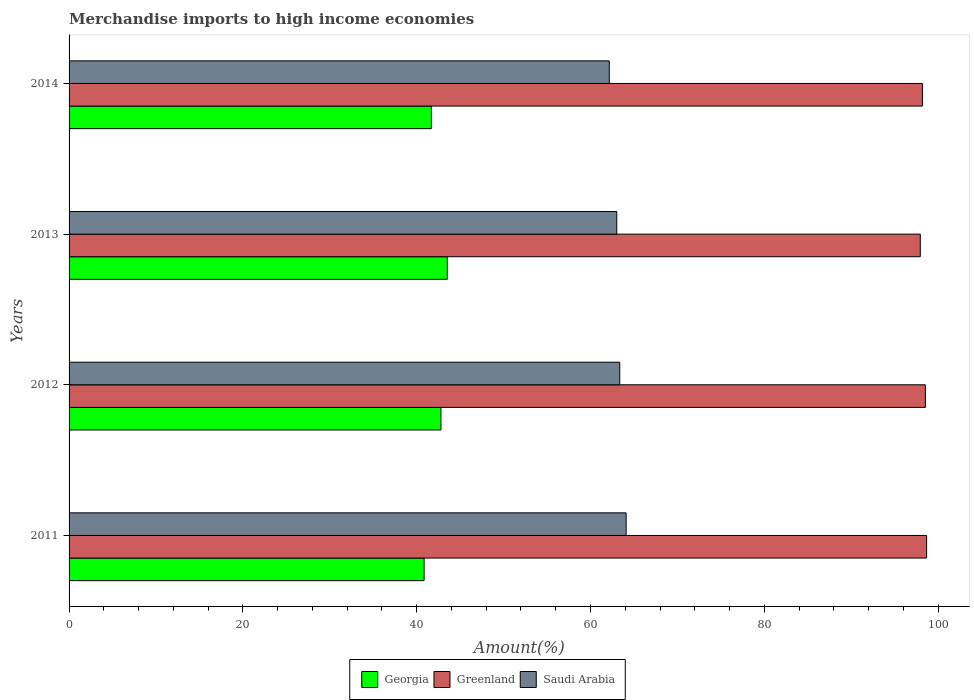How many different coloured bars are there?
Provide a succinct answer. 3. Are the number of bars on each tick of the Y-axis equal?
Offer a very short reply. Yes. How many bars are there on the 1st tick from the top?
Give a very brief answer. 3. What is the label of the 3rd group of bars from the top?
Offer a terse response. 2012. In how many cases, is the number of bars for a given year not equal to the number of legend labels?
Your response must be concise. 0. What is the percentage of amount earned from merchandise imports in Saudi Arabia in 2012?
Your answer should be very brief. 63.37. Across all years, what is the maximum percentage of amount earned from merchandise imports in Greenland?
Ensure brevity in your answer.  98.68. Across all years, what is the minimum percentage of amount earned from merchandise imports in Saudi Arabia?
Offer a very short reply. 62.16. In which year was the percentage of amount earned from merchandise imports in Saudi Arabia maximum?
Ensure brevity in your answer.  2011. What is the total percentage of amount earned from merchandise imports in Saudi Arabia in the graph?
Offer a very short reply. 252.65. What is the difference between the percentage of amount earned from merchandise imports in Georgia in 2012 and that in 2014?
Provide a succinct answer. 1.1. What is the difference between the percentage of amount earned from merchandise imports in Saudi Arabia in 2014 and the percentage of amount earned from merchandise imports in Georgia in 2013?
Offer a terse response. 18.64. What is the average percentage of amount earned from merchandise imports in Greenland per year?
Your response must be concise. 98.34. In the year 2013, what is the difference between the percentage of amount earned from merchandise imports in Saudi Arabia and percentage of amount earned from merchandise imports in Georgia?
Provide a short and direct response. 19.5. What is the ratio of the percentage of amount earned from merchandise imports in Greenland in 2011 to that in 2012?
Your response must be concise. 1. Is the percentage of amount earned from merchandise imports in Saudi Arabia in 2011 less than that in 2012?
Offer a very short reply. No. What is the difference between the highest and the second highest percentage of amount earned from merchandise imports in Georgia?
Your answer should be very brief. 0.73. What is the difference between the highest and the lowest percentage of amount earned from merchandise imports in Georgia?
Offer a terse response. 2.67. Is the sum of the percentage of amount earned from merchandise imports in Greenland in 2011 and 2013 greater than the maximum percentage of amount earned from merchandise imports in Saudi Arabia across all years?
Your response must be concise. Yes. What does the 2nd bar from the top in 2013 represents?
Ensure brevity in your answer.  Greenland. What does the 2nd bar from the bottom in 2014 represents?
Ensure brevity in your answer.  Greenland. How many bars are there?
Offer a very short reply. 12. What is the difference between two consecutive major ticks on the X-axis?
Keep it short and to the point. 20. Does the graph contain any zero values?
Provide a short and direct response. No. Does the graph contain grids?
Offer a very short reply. No. How many legend labels are there?
Provide a short and direct response. 3. How are the legend labels stacked?
Provide a succinct answer. Horizontal. What is the title of the graph?
Keep it short and to the point. Merchandise imports to high income economies. What is the label or title of the X-axis?
Offer a very short reply. Amount(%). What is the Amount(%) of Georgia in 2011?
Offer a very short reply. 40.85. What is the Amount(%) of Greenland in 2011?
Provide a short and direct response. 98.68. What is the Amount(%) in Saudi Arabia in 2011?
Give a very brief answer. 64.1. What is the Amount(%) of Georgia in 2012?
Give a very brief answer. 42.79. What is the Amount(%) of Greenland in 2012?
Provide a short and direct response. 98.54. What is the Amount(%) in Saudi Arabia in 2012?
Offer a terse response. 63.37. What is the Amount(%) of Georgia in 2013?
Provide a short and direct response. 43.52. What is the Amount(%) of Greenland in 2013?
Ensure brevity in your answer.  97.95. What is the Amount(%) in Saudi Arabia in 2013?
Keep it short and to the point. 63.02. What is the Amount(%) of Georgia in 2014?
Offer a very short reply. 41.69. What is the Amount(%) in Greenland in 2014?
Provide a short and direct response. 98.2. What is the Amount(%) in Saudi Arabia in 2014?
Your answer should be compact. 62.16. Across all years, what is the maximum Amount(%) in Georgia?
Give a very brief answer. 43.52. Across all years, what is the maximum Amount(%) of Greenland?
Provide a short and direct response. 98.68. Across all years, what is the maximum Amount(%) of Saudi Arabia?
Give a very brief answer. 64.1. Across all years, what is the minimum Amount(%) of Georgia?
Offer a very short reply. 40.85. Across all years, what is the minimum Amount(%) in Greenland?
Offer a terse response. 97.95. Across all years, what is the minimum Amount(%) in Saudi Arabia?
Offer a terse response. 62.16. What is the total Amount(%) of Georgia in the graph?
Your response must be concise. 168.86. What is the total Amount(%) in Greenland in the graph?
Offer a very short reply. 393.36. What is the total Amount(%) in Saudi Arabia in the graph?
Provide a short and direct response. 252.65. What is the difference between the Amount(%) of Georgia in 2011 and that in 2012?
Make the answer very short. -1.94. What is the difference between the Amount(%) of Greenland in 2011 and that in 2012?
Offer a very short reply. 0.14. What is the difference between the Amount(%) in Saudi Arabia in 2011 and that in 2012?
Offer a terse response. 0.74. What is the difference between the Amount(%) of Georgia in 2011 and that in 2013?
Your answer should be very brief. -2.67. What is the difference between the Amount(%) of Greenland in 2011 and that in 2013?
Provide a short and direct response. 0.73. What is the difference between the Amount(%) in Saudi Arabia in 2011 and that in 2013?
Your response must be concise. 1.08. What is the difference between the Amount(%) in Georgia in 2011 and that in 2014?
Give a very brief answer. -0.84. What is the difference between the Amount(%) in Greenland in 2011 and that in 2014?
Ensure brevity in your answer.  0.48. What is the difference between the Amount(%) of Saudi Arabia in 2011 and that in 2014?
Provide a short and direct response. 1.94. What is the difference between the Amount(%) in Georgia in 2012 and that in 2013?
Offer a terse response. -0.73. What is the difference between the Amount(%) of Greenland in 2012 and that in 2013?
Make the answer very short. 0.59. What is the difference between the Amount(%) of Saudi Arabia in 2012 and that in 2013?
Your response must be concise. 0.34. What is the difference between the Amount(%) of Georgia in 2012 and that in 2014?
Your response must be concise. 1.1. What is the difference between the Amount(%) of Greenland in 2012 and that in 2014?
Make the answer very short. 0.34. What is the difference between the Amount(%) of Saudi Arabia in 2012 and that in 2014?
Your response must be concise. 1.2. What is the difference between the Amount(%) in Georgia in 2013 and that in 2014?
Offer a very short reply. 1.83. What is the difference between the Amount(%) of Greenland in 2013 and that in 2014?
Make the answer very short. -0.25. What is the difference between the Amount(%) in Saudi Arabia in 2013 and that in 2014?
Offer a terse response. 0.86. What is the difference between the Amount(%) in Georgia in 2011 and the Amount(%) in Greenland in 2012?
Provide a succinct answer. -57.68. What is the difference between the Amount(%) in Georgia in 2011 and the Amount(%) in Saudi Arabia in 2012?
Give a very brief answer. -22.51. What is the difference between the Amount(%) of Greenland in 2011 and the Amount(%) of Saudi Arabia in 2012?
Give a very brief answer. 35.31. What is the difference between the Amount(%) of Georgia in 2011 and the Amount(%) of Greenland in 2013?
Keep it short and to the point. -57.1. What is the difference between the Amount(%) of Georgia in 2011 and the Amount(%) of Saudi Arabia in 2013?
Keep it short and to the point. -22.17. What is the difference between the Amount(%) in Greenland in 2011 and the Amount(%) in Saudi Arabia in 2013?
Offer a terse response. 35.65. What is the difference between the Amount(%) of Georgia in 2011 and the Amount(%) of Greenland in 2014?
Keep it short and to the point. -57.34. What is the difference between the Amount(%) in Georgia in 2011 and the Amount(%) in Saudi Arabia in 2014?
Your answer should be very brief. -21.31. What is the difference between the Amount(%) of Greenland in 2011 and the Amount(%) of Saudi Arabia in 2014?
Ensure brevity in your answer.  36.52. What is the difference between the Amount(%) of Georgia in 2012 and the Amount(%) of Greenland in 2013?
Ensure brevity in your answer.  -55.16. What is the difference between the Amount(%) of Georgia in 2012 and the Amount(%) of Saudi Arabia in 2013?
Your answer should be compact. -20.23. What is the difference between the Amount(%) of Greenland in 2012 and the Amount(%) of Saudi Arabia in 2013?
Provide a succinct answer. 35.51. What is the difference between the Amount(%) of Georgia in 2012 and the Amount(%) of Greenland in 2014?
Your answer should be very brief. -55.41. What is the difference between the Amount(%) in Georgia in 2012 and the Amount(%) in Saudi Arabia in 2014?
Offer a very short reply. -19.37. What is the difference between the Amount(%) in Greenland in 2012 and the Amount(%) in Saudi Arabia in 2014?
Your answer should be very brief. 36.37. What is the difference between the Amount(%) of Georgia in 2013 and the Amount(%) of Greenland in 2014?
Make the answer very short. -54.67. What is the difference between the Amount(%) of Georgia in 2013 and the Amount(%) of Saudi Arabia in 2014?
Ensure brevity in your answer.  -18.64. What is the difference between the Amount(%) of Greenland in 2013 and the Amount(%) of Saudi Arabia in 2014?
Keep it short and to the point. 35.79. What is the average Amount(%) of Georgia per year?
Provide a succinct answer. 42.21. What is the average Amount(%) of Greenland per year?
Your answer should be compact. 98.34. What is the average Amount(%) of Saudi Arabia per year?
Make the answer very short. 63.16. In the year 2011, what is the difference between the Amount(%) of Georgia and Amount(%) of Greenland?
Make the answer very short. -57.82. In the year 2011, what is the difference between the Amount(%) in Georgia and Amount(%) in Saudi Arabia?
Your response must be concise. -23.25. In the year 2011, what is the difference between the Amount(%) of Greenland and Amount(%) of Saudi Arabia?
Give a very brief answer. 34.57. In the year 2012, what is the difference between the Amount(%) of Georgia and Amount(%) of Greenland?
Ensure brevity in your answer.  -55.74. In the year 2012, what is the difference between the Amount(%) in Georgia and Amount(%) in Saudi Arabia?
Offer a very short reply. -20.57. In the year 2012, what is the difference between the Amount(%) in Greenland and Amount(%) in Saudi Arabia?
Provide a short and direct response. 35.17. In the year 2013, what is the difference between the Amount(%) of Georgia and Amount(%) of Greenland?
Ensure brevity in your answer.  -54.43. In the year 2013, what is the difference between the Amount(%) of Georgia and Amount(%) of Saudi Arabia?
Offer a very short reply. -19.5. In the year 2013, what is the difference between the Amount(%) of Greenland and Amount(%) of Saudi Arabia?
Offer a very short reply. 34.92. In the year 2014, what is the difference between the Amount(%) of Georgia and Amount(%) of Greenland?
Provide a short and direct response. -56.5. In the year 2014, what is the difference between the Amount(%) of Georgia and Amount(%) of Saudi Arabia?
Provide a succinct answer. -20.47. In the year 2014, what is the difference between the Amount(%) in Greenland and Amount(%) in Saudi Arabia?
Provide a succinct answer. 36.03. What is the ratio of the Amount(%) in Georgia in 2011 to that in 2012?
Offer a terse response. 0.95. What is the ratio of the Amount(%) of Greenland in 2011 to that in 2012?
Provide a succinct answer. 1. What is the ratio of the Amount(%) in Saudi Arabia in 2011 to that in 2012?
Offer a very short reply. 1.01. What is the ratio of the Amount(%) of Georgia in 2011 to that in 2013?
Offer a very short reply. 0.94. What is the ratio of the Amount(%) in Greenland in 2011 to that in 2013?
Offer a very short reply. 1.01. What is the ratio of the Amount(%) of Saudi Arabia in 2011 to that in 2013?
Provide a succinct answer. 1.02. What is the ratio of the Amount(%) in Georgia in 2011 to that in 2014?
Your response must be concise. 0.98. What is the ratio of the Amount(%) of Saudi Arabia in 2011 to that in 2014?
Your answer should be compact. 1.03. What is the ratio of the Amount(%) in Georgia in 2012 to that in 2013?
Your response must be concise. 0.98. What is the ratio of the Amount(%) of Saudi Arabia in 2012 to that in 2013?
Offer a terse response. 1.01. What is the ratio of the Amount(%) in Georgia in 2012 to that in 2014?
Your answer should be compact. 1.03. What is the ratio of the Amount(%) in Greenland in 2012 to that in 2014?
Offer a terse response. 1. What is the ratio of the Amount(%) of Saudi Arabia in 2012 to that in 2014?
Give a very brief answer. 1.02. What is the ratio of the Amount(%) of Georgia in 2013 to that in 2014?
Your answer should be very brief. 1.04. What is the ratio of the Amount(%) of Saudi Arabia in 2013 to that in 2014?
Ensure brevity in your answer.  1.01. What is the difference between the highest and the second highest Amount(%) in Georgia?
Your response must be concise. 0.73. What is the difference between the highest and the second highest Amount(%) of Greenland?
Your answer should be compact. 0.14. What is the difference between the highest and the second highest Amount(%) of Saudi Arabia?
Give a very brief answer. 0.74. What is the difference between the highest and the lowest Amount(%) in Georgia?
Offer a very short reply. 2.67. What is the difference between the highest and the lowest Amount(%) of Greenland?
Make the answer very short. 0.73. What is the difference between the highest and the lowest Amount(%) in Saudi Arabia?
Ensure brevity in your answer.  1.94. 